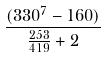<formula> <loc_0><loc_0><loc_500><loc_500>\frac { ( 3 3 0 ^ { 7 } - 1 6 0 ) } { \frac { 2 5 3 } { 4 1 9 } + 2 }</formula> 